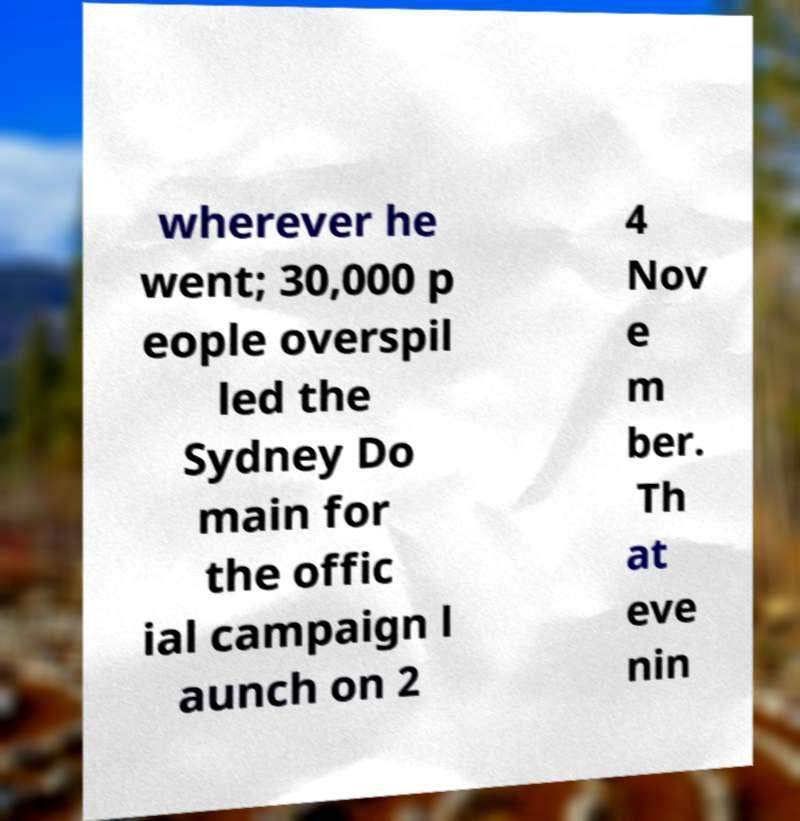Please identify and transcribe the text found in this image. wherever he went; 30,000 p eople overspil led the Sydney Do main for the offic ial campaign l aunch on 2 4 Nov e m ber. Th at eve nin 